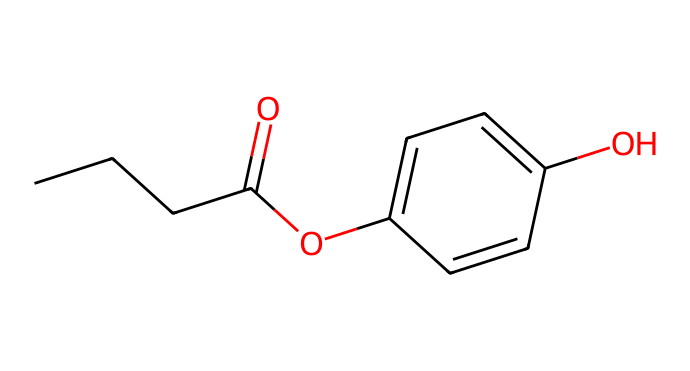What is the primary functional group in this molecule? The structure contains an ester functional group, identified by the -O-C(=O)- bond. This is derived from the carbonyl (C=O) and the ether (C-O) linkage.
Answer: ester How many rings are present in this chemical structure? Upon examining the structure, there is one cyclic component indicated by the ring formed by five carbon atoms and the participating double bonds.
Answer: one What is the total number of carbon atoms in propylparaben? Counting the carbon atoms in the structure, there are a total of 10 carbon atoms, including those in the propyl group and the aromatic ring.
Answer: ten Which part of this molecule contributes to its preservative properties? The para-hydroxyl group (-OH) on the aromatic ring significantly contributes to the biological activity as a preservative by inhibiting microbial growth.
Answer: para-hydroxyl group Does this compound contain any heteroatoms? Looking at the molecular structure, the only heteroatom present is oxygen, as evident in the ester and hydroxyl groups.
Answer: yes What type of chemical compound is propylparaben classified as? This molecule is classified as a preservative, specifically a paraben, which is used to inhibit microbial growth in various products.
Answer: paraben What is the molecular formula of propylparaben? Analyzing the structure, the molecular formula can be derived as C10H12O3, indicating a specific count of each atom type in the compound.
Answer: C10H12O3 